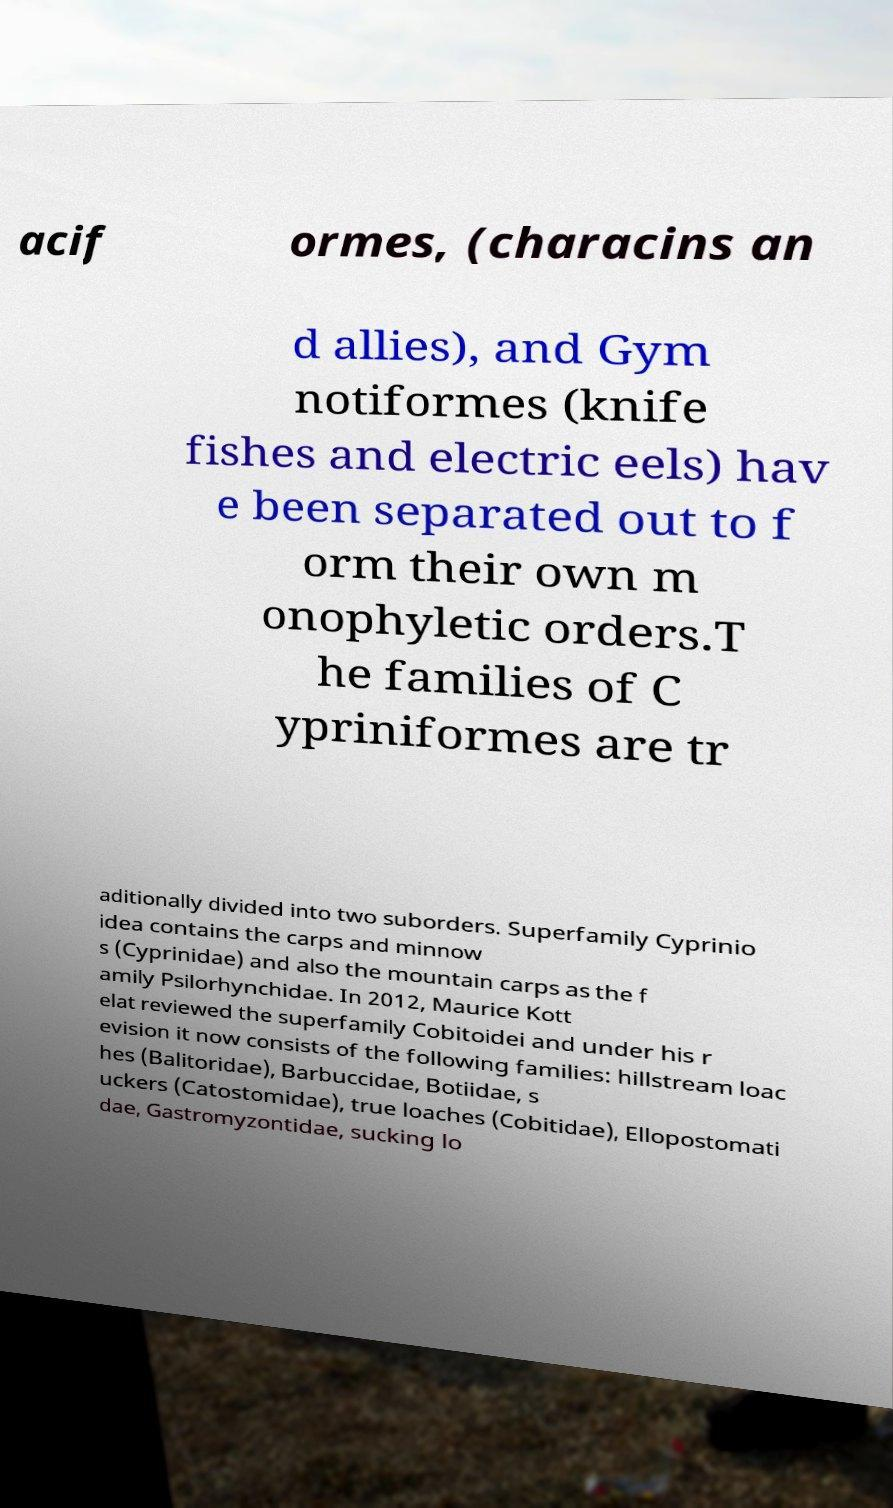Please read and relay the text visible in this image. What does it say? acif ormes, (characins an d allies), and Gym notiformes (knife fishes and electric eels) hav e been separated out to f orm their own m onophyletic orders.T he families of C ypriniformes are tr aditionally divided into two suborders. Superfamily Cyprinio idea contains the carps and minnow s (Cyprinidae) and also the mountain carps as the f amily Psilorhynchidae. In 2012, Maurice Kott elat reviewed the superfamily Cobitoidei and under his r evision it now consists of the following families: hillstream loac hes (Balitoridae), Barbuccidae, Botiidae, s uckers (Catostomidae), true loaches (Cobitidae), Ellopostomati dae, Gastromyzontidae, sucking lo 